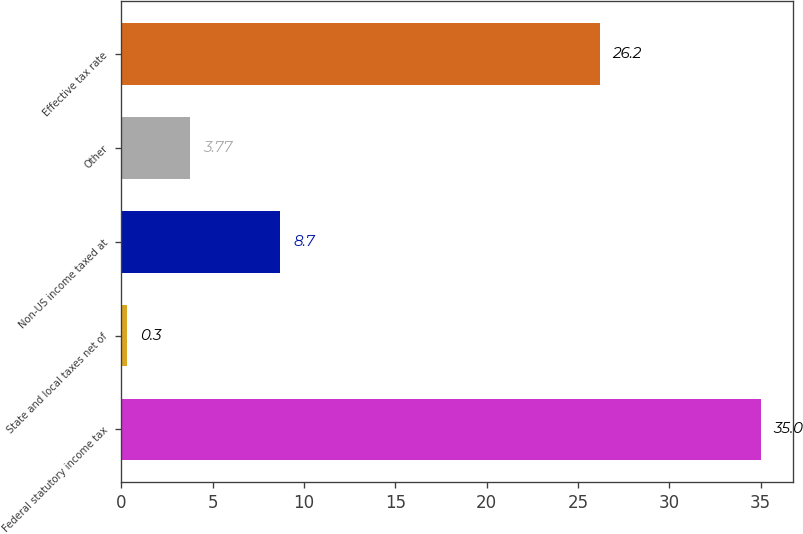<chart> <loc_0><loc_0><loc_500><loc_500><bar_chart><fcel>Federal statutory income tax<fcel>State and local taxes net of<fcel>Non-US income taxed at<fcel>Other<fcel>Effective tax rate<nl><fcel>35<fcel>0.3<fcel>8.7<fcel>3.77<fcel>26.2<nl></chart> 